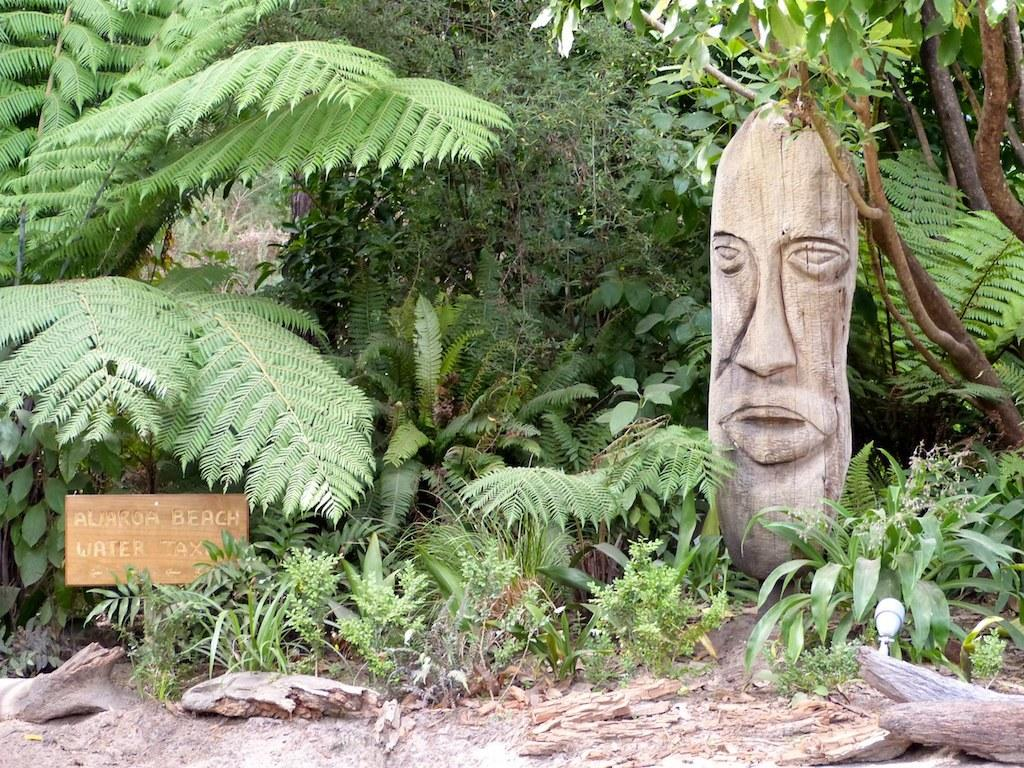What type of natural elements are present in the image? There are trees and plants in the image. What is the purpose of the board in the image? There is text written on a board in the image, which suggests it might be used for communication or displaying information. What can be seen on the right side of the image? There is a sculpture on the right side of the image. What type of objects are present at the bottom of the image? There are wooden objects present at the bottom of the image. How many children are playing dress-up in the image? There are no children or dress-up activities present in the image. 